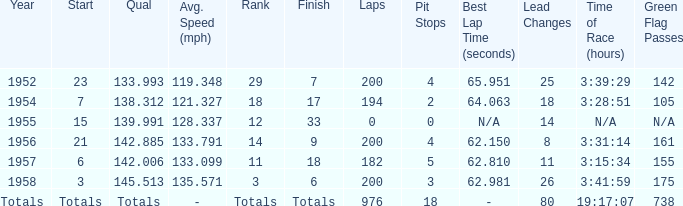What place did Jimmy Reece finish in 1957? 18.0. 